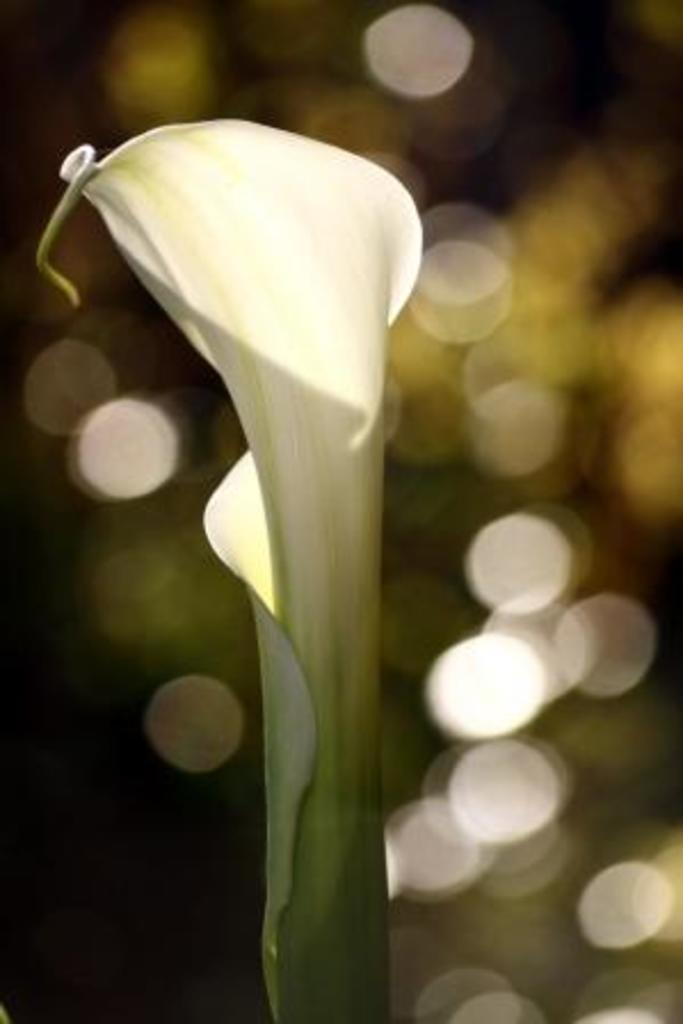What type of objects can be seen in the image? There are petals in the image. What colors are the petals? The petals are of white and green color. Can you describe the background of the image? The background of the image is blurred. Are there any marbles visible in the image? There are no marbles present in the image; it features petals of white and green color. Can you tell me how many bones are depicted in the image? There are no bones depicted in the image; it features petals of white and green color. 